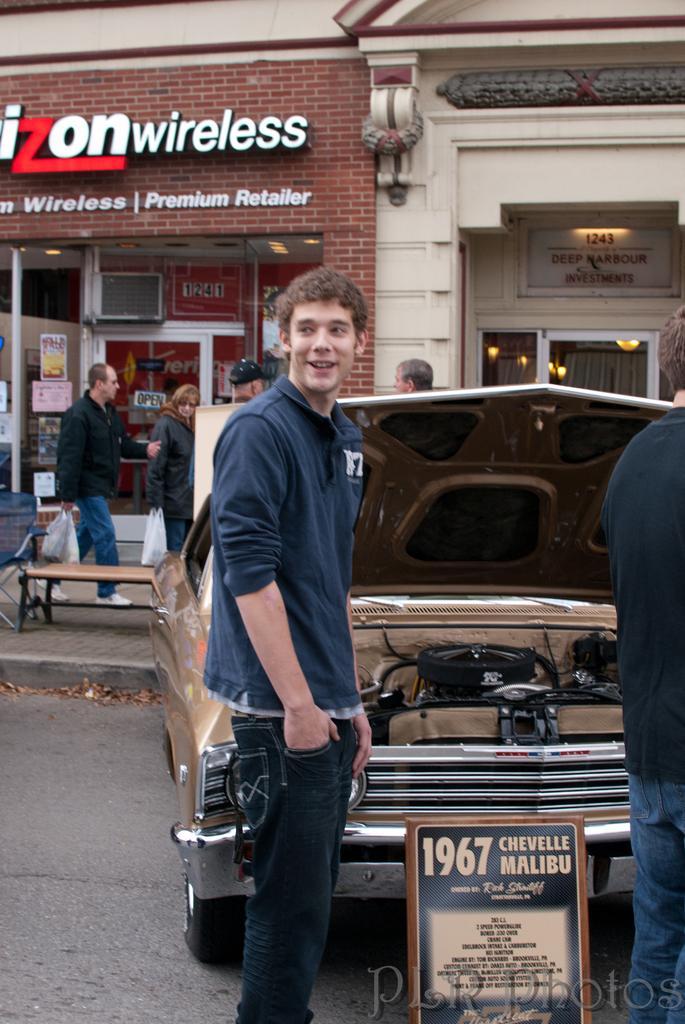How would you summarize this image in a sentence or two? In this picture we can see two people standing, board, vehicle on the road, man smiling and at the back of him we can see some people, posters, lights, curtains, walls, bench, chair and some objects. 